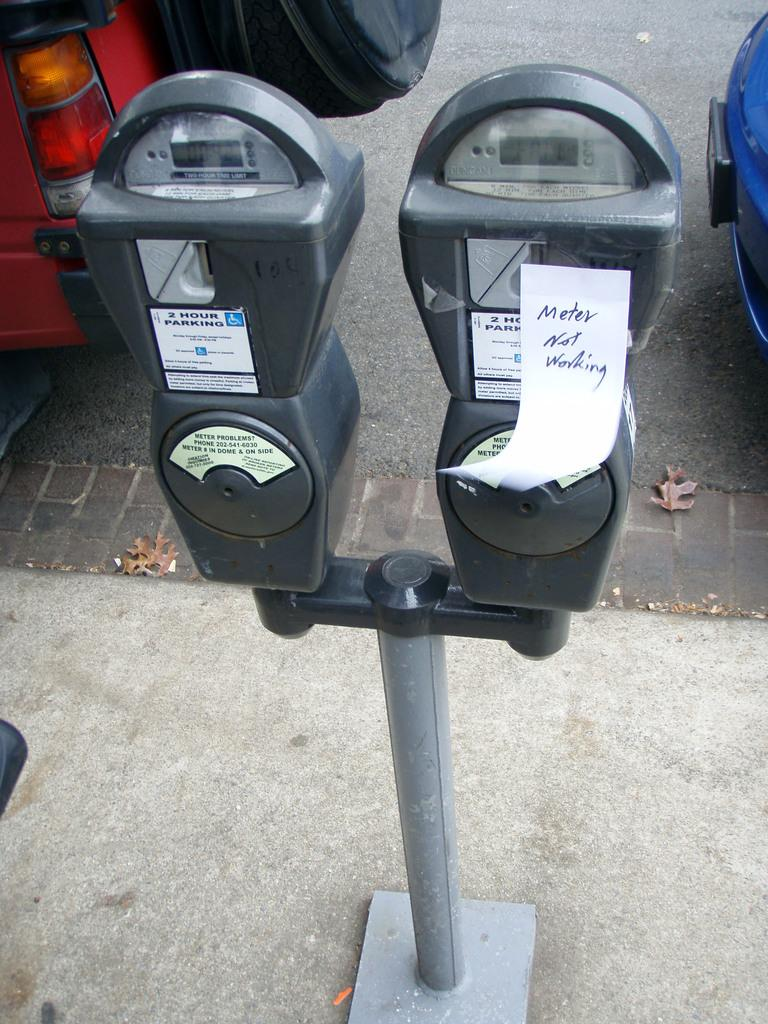<image>
Give a short and clear explanation of the subsequent image. A pair of parking meters and a note on the right one that says Meter not working. 